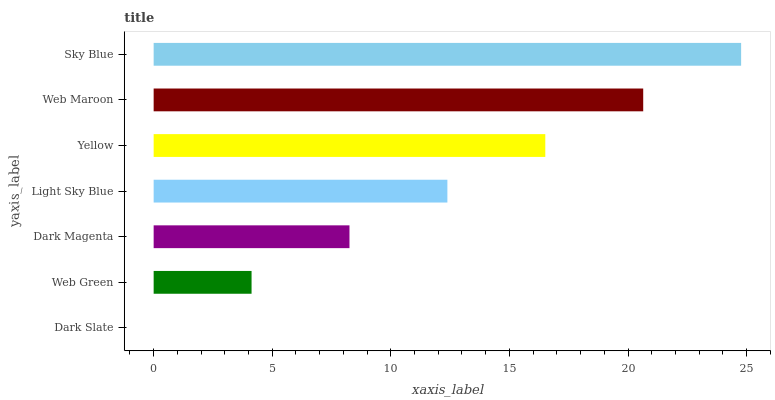Is Dark Slate the minimum?
Answer yes or no. Yes. Is Sky Blue the maximum?
Answer yes or no. Yes. Is Web Green the minimum?
Answer yes or no. No. Is Web Green the maximum?
Answer yes or no. No. Is Web Green greater than Dark Slate?
Answer yes or no. Yes. Is Dark Slate less than Web Green?
Answer yes or no. Yes. Is Dark Slate greater than Web Green?
Answer yes or no. No. Is Web Green less than Dark Slate?
Answer yes or no. No. Is Light Sky Blue the high median?
Answer yes or no. Yes. Is Light Sky Blue the low median?
Answer yes or no. Yes. Is Dark Slate the high median?
Answer yes or no. No. Is Web Maroon the low median?
Answer yes or no. No. 